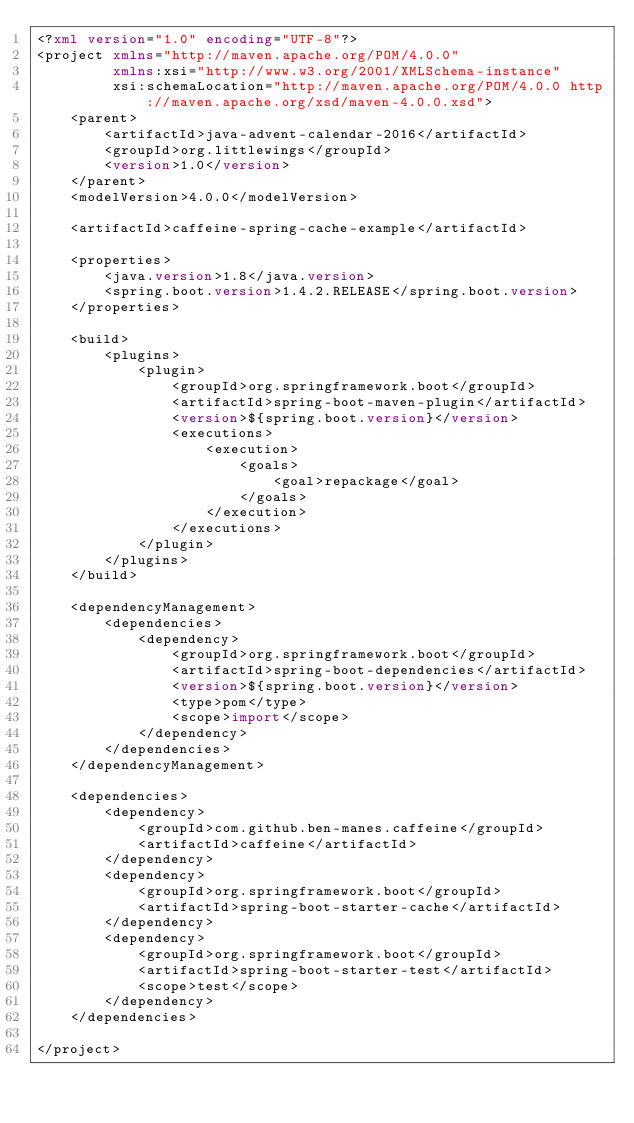<code> <loc_0><loc_0><loc_500><loc_500><_XML_><?xml version="1.0" encoding="UTF-8"?>
<project xmlns="http://maven.apache.org/POM/4.0.0"
         xmlns:xsi="http://www.w3.org/2001/XMLSchema-instance"
         xsi:schemaLocation="http://maven.apache.org/POM/4.0.0 http://maven.apache.org/xsd/maven-4.0.0.xsd">
    <parent>
        <artifactId>java-advent-calendar-2016</artifactId>
        <groupId>org.littlewings</groupId>
        <version>1.0</version>
    </parent>
    <modelVersion>4.0.0</modelVersion>

    <artifactId>caffeine-spring-cache-example</artifactId>

    <properties>
        <java.version>1.8</java.version>
        <spring.boot.version>1.4.2.RELEASE</spring.boot.version>
    </properties>

    <build>
        <plugins>
            <plugin>
                <groupId>org.springframework.boot</groupId>
                <artifactId>spring-boot-maven-plugin</artifactId>
                <version>${spring.boot.version}</version>
                <executions>
                    <execution>
                        <goals>
                            <goal>repackage</goal>
                        </goals>
                    </execution>
                </executions>
            </plugin>
        </plugins>
    </build>

    <dependencyManagement>
        <dependencies>
            <dependency>
                <groupId>org.springframework.boot</groupId>
                <artifactId>spring-boot-dependencies</artifactId>
                <version>${spring.boot.version}</version>
                <type>pom</type>
                <scope>import</scope>
            </dependency>
        </dependencies>
    </dependencyManagement>

    <dependencies>
        <dependency>
            <groupId>com.github.ben-manes.caffeine</groupId>
            <artifactId>caffeine</artifactId>
        </dependency>
        <dependency>
            <groupId>org.springframework.boot</groupId>
            <artifactId>spring-boot-starter-cache</artifactId>
        </dependency>
        <dependency>
            <groupId>org.springframework.boot</groupId>
            <artifactId>spring-boot-starter-test</artifactId>
            <scope>test</scope>
        </dependency>
    </dependencies>

</project></code> 